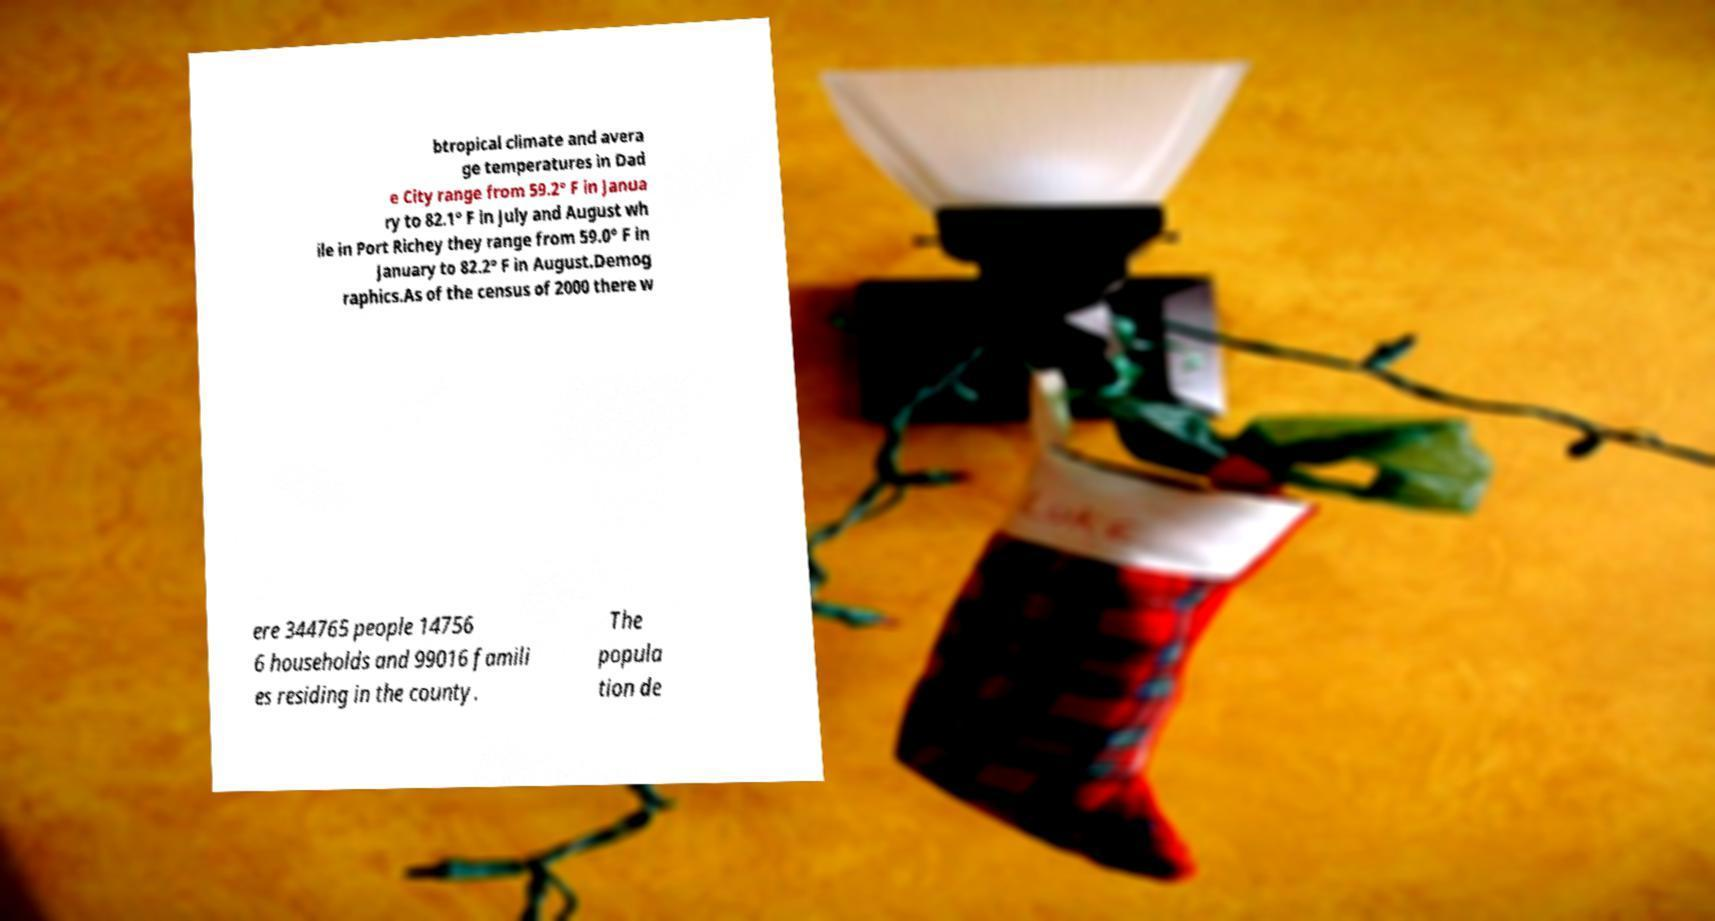Please read and relay the text visible in this image. What does it say? btropical climate and avera ge temperatures in Dad e City range from 59.2° F in Janua ry to 82.1° F in July and August wh ile in Port Richey they range from 59.0° F in January to 82.2° F in August.Demog raphics.As of the census of 2000 there w ere 344765 people 14756 6 households and 99016 famili es residing in the county. The popula tion de 